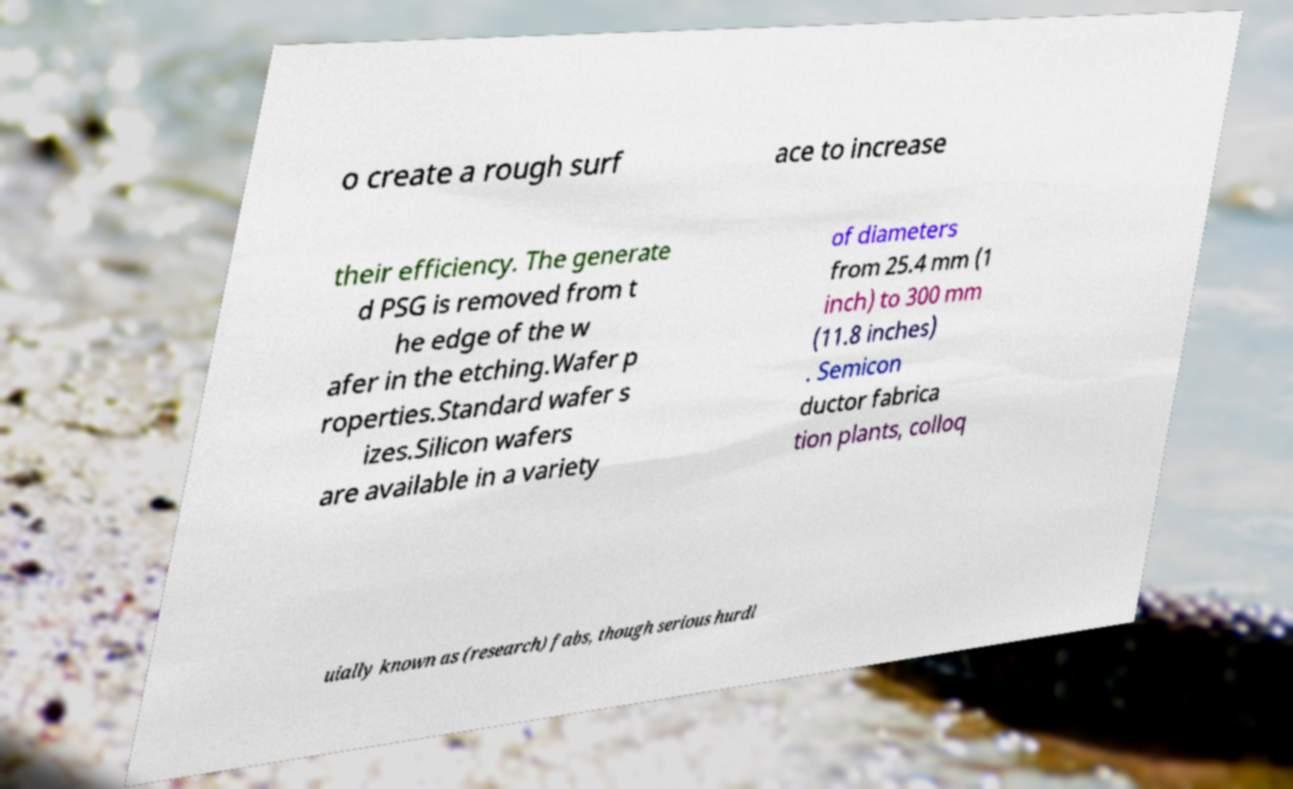Could you extract and type out the text from this image? o create a rough surf ace to increase their efficiency. The generate d PSG is removed from t he edge of the w afer in the etching.Wafer p roperties.Standard wafer s izes.Silicon wafers are available in a variety of diameters from 25.4 mm (1 inch) to 300 mm (11.8 inches) . Semicon ductor fabrica tion plants, colloq uially known as (research) fabs, though serious hurdl 